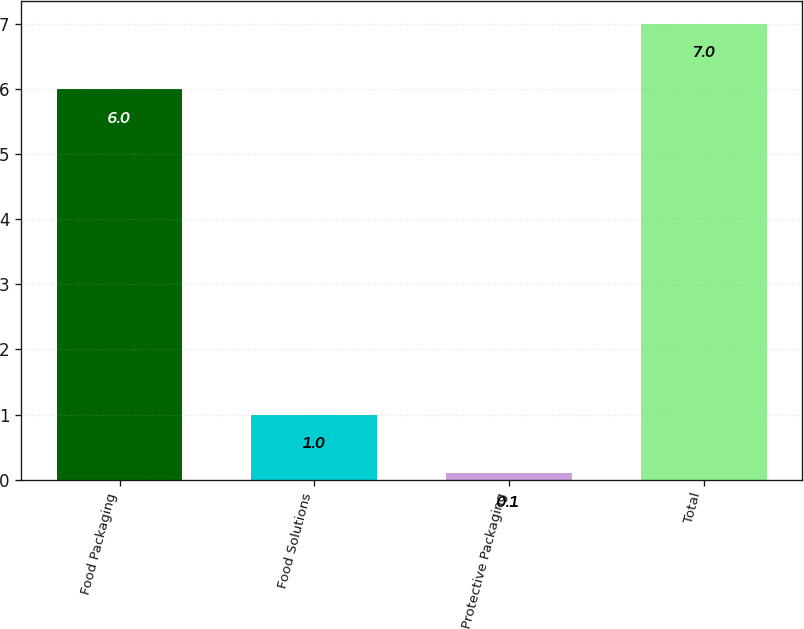Convert chart to OTSL. <chart><loc_0><loc_0><loc_500><loc_500><bar_chart><fcel>Food Packaging<fcel>Food Solutions<fcel>Protective Packaging<fcel>Total<nl><fcel>6<fcel>1<fcel>0.1<fcel>7<nl></chart> 